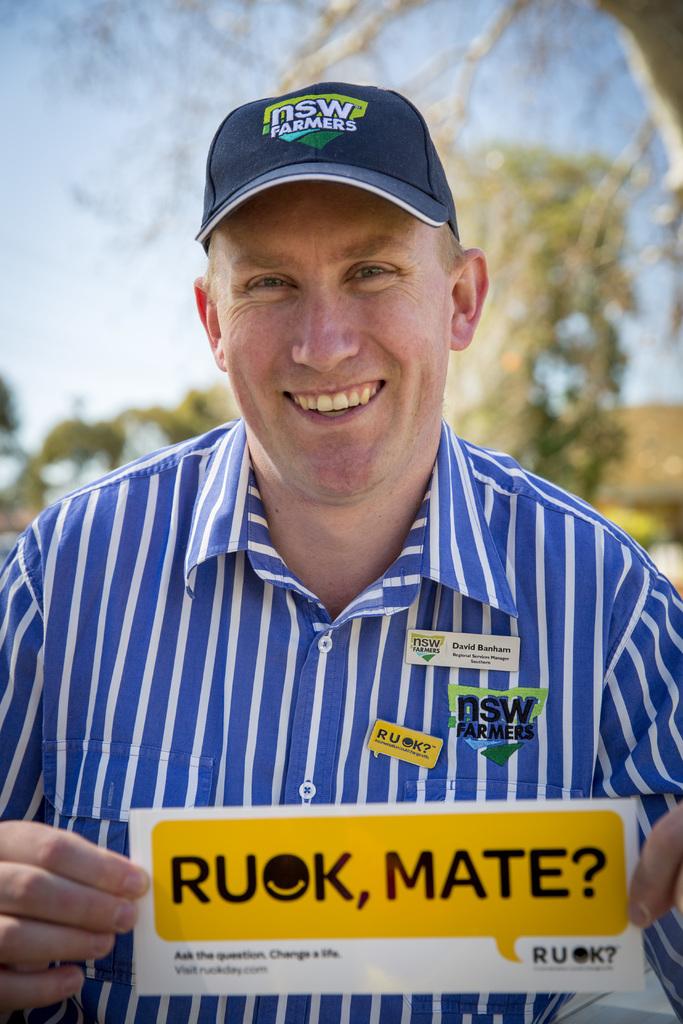What is the man's company logo?
Your answer should be compact. Nsw. What does it say on his hat?
Your answer should be compact. Nsw farmers. 